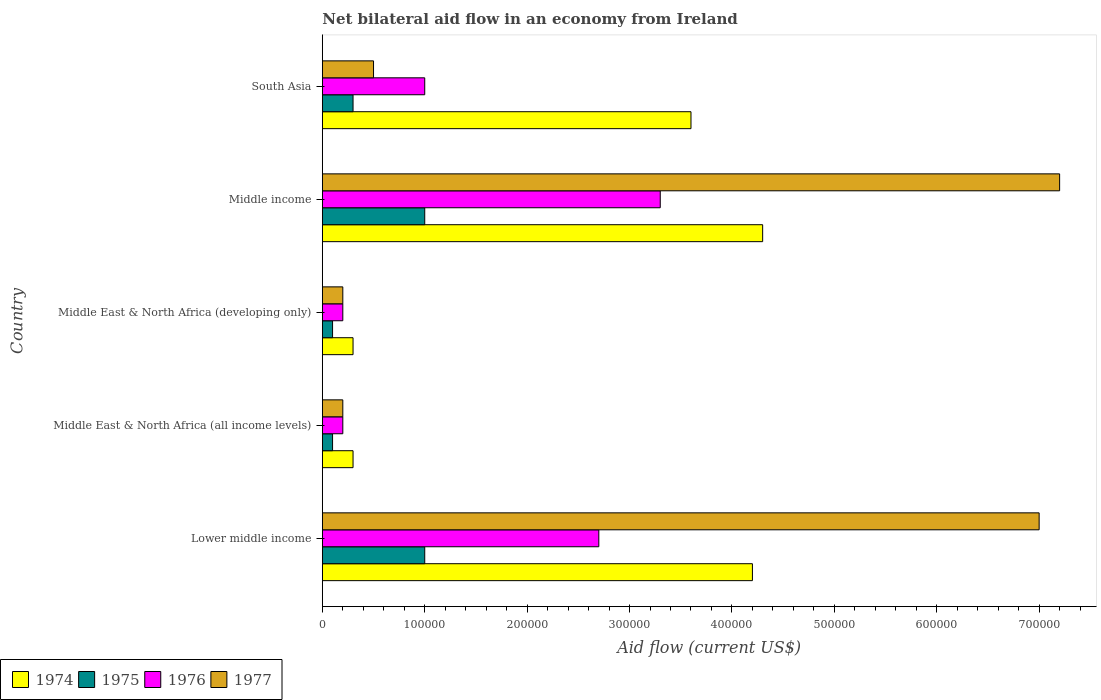How many different coloured bars are there?
Give a very brief answer. 4. How many groups of bars are there?
Your response must be concise. 5. Are the number of bars per tick equal to the number of legend labels?
Offer a very short reply. Yes. How many bars are there on the 1st tick from the top?
Ensure brevity in your answer.  4. How many bars are there on the 5th tick from the bottom?
Your answer should be compact. 4. What is the label of the 2nd group of bars from the top?
Offer a very short reply. Middle income. In how many cases, is the number of bars for a given country not equal to the number of legend labels?
Your answer should be compact. 0. What is the net bilateral aid flow in 1976 in South Asia?
Keep it short and to the point. 1.00e+05. Across all countries, what is the minimum net bilateral aid flow in 1977?
Give a very brief answer. 2.00e+04. In which country was the net bilateral aid flow in 1975 maximum?
Your response must be concise. Lower middle income. In which country was the net bilateral aid flow in 1977 minimum?
Your answer should be very brief. Middle East & North Africa (all income levels). What is the total net bilateral aid flow in 1977 in the graph?
Your answer should be compact. 1.51e+06. What is the difference between the net bilateral aid flow in 1974 in Middle income and that in South Asia?
Ensure brevity in your answer.  7.00e+04. What is the difference between the net bilateral aid flow in 1975 in Lower middle income and the net bilateral aid flow in 1976 in Middle income?
Ensure brevity in your answer.  -2.30e+05. What is the average net bilateral aid flow in 1977 per country?
Make the answer very short. 3.02e+05. What is the difference between the net bilateral aid flow in 1977 and net bilateral aid flow in 1974 in Middle East & North Africa (all income levels)?
Your response must be concise. -10000. What is the ratio of the net bilateral aid flow in 1976 in Middle East & North Africa (all income levels) to that in Middle income?
Ensure brevity in your answer.  0.06. Is the net bilateral aid flow in 1976 in Middle income less than that in South Asia?
Offer a terse response. No. What is the difference between the highest and the second highest net bilateral aid flow in 1975?
Provide a short and direct response. 0. What is the difference between the highest and the lowest net bilateral aid flow in 1976?
Your response must be concise. 3.10e+05. Is it the case that in every country, the sum of the net bilateral aid flow in 1974 and net bilateral aid flow in 1975 is greater than the sum of net bilateral aid flow in 1977 and net bilateral aid flow in 1976?
Provide a succinct answer. No. What does the 1st bar from the top in Lower middle income represents?
Provide a succinct answer. 1977. What does the 1st bar from the bottom in Middle East & North Africa (all income levels) represents?
Ensure brevity in your answer.  1974. Is it the case that in every country, the sum of the net bilateral aid flow in 1975 and net bilateral aid flow in 1974 is greater than the net bilateral aid flow in 1977?
Make the answer very short. No. Are all the bars in the graph horizontal?
Provide a short and direct response. Yes. What is the difference between two consecutive major ticks on the X-axis?
Your answer should be compact. 1.00e+05. Does the graph contain any zero values?
Your answer should be compact. No. Where does the legend appear in the graph?
Your answer should be very brief. Bottom left. How many legend labels are there?
Ensure brevity in your answer.  4. What is the title of the graph?
Offer a terse response. Net bilateral aid flow in an economy from Ireland. Does "1995" appear as one of the legend labels in the graph?
Provide a short and direct response. No. What is the Aid flow (current US$) of 1974 in Lower middle income?
Keep it short and to the point. 4.20e+05. What is the Aid flow (current US$) of 1975 in Lower middle income?
Keep it short and to the point. 1.00e+05. What is the Aid flow (current US$) in 1974 in Middle East & North Africa (all income levels)?
Offer a terse response. 3.00e+04. What is the Aid flow (current US$) in 1975 in Middle East & North Africa (all income levels)?
Your answer should be compact. 10000. What is the Aid flow (current US$) of 1976 in Middle East & North Africa (all income levels)?
Your response must be concise. 2.00e+04. What is the Aid flow (current US$) in 1976 in Middle East & North Africa (developing only)?
Keep it short and to the point. 2.00e+04. What is the Aid flow (current US$) in 1977 in Middle East & North Africa (developing only)?
Make the answer very short. 2.00e+04. What is the Aid flow (current US$) of 1975 in Middle income?
Your response must be concise. 1.00e+05. What is the Aid flow (current US$) of 1976 in Middle income?
Keep it short and to the point. 3.30e+05. What is the Aid flow (current US$) in 1977 in Middle income?
Your answer should be compact. 7.20e+05. What is the Aid flow (current US$) in 1975 in South Asia?
Your answer should be very brief. 3.00e+04. What is the Aid flow (current US$) of 1977 in South Asia?
Your answer should be compact. 5.00e+04. Across all countries, what is the maximum Aid flow (current US$) in 1976?
Provide a succinct answer. 3.30e+05. Across all countries, what is the maximum Aid flow (current US$) in 1977?
Keep it short and to the point. 7.20e+05. Across all countries, what is the minimum Aid flow (current US$) of 1975?
Give a very brief answer. 10000. Across all countries, what is the minimum Aid flow (current US$) of 1976?
Offer a very short reply. 2.00e+04. Across all countries, what is the minimum Aid flow (current US$) of 1977?
Give a very brief answer. 2.00e+04. What is the total Aid flow (current US$) in 1974 in the graph?
Offer a terse response. 1.27e+06. What is the total Aid flow (current US$) in 1976 in the graph?
Offer a very short reply. 7.40e+05. What is the total Aid flow (current US$) in 1977 in the graph?
Your answer should be very brief. 1.51e+06. What is the difference between the Aid flow (current US$) of 1977 in Lower middle income and that in Middle East & North Africa (all income levels)?
Make the answer very short. 6.80e+05. What is the difference between the Aid flow (current US$) in 1974 in Lower middle income and that in Middle East & North Africa (developing only)?
Make the answer very short. 3.90e+05. What is the difference between the Aid flow (current US$) of 1976 in Lower middle income and that in Middle East & North Africa (developing only)?
Offer a very short reply. 2.50e+05. What is the difference between the Aid flow (current US$) of 1977 in Lower middle income and that in Middle East & North Africa (developing only)?
Your response must be concise. 6.80e+05. What is the difference between the Aid flow (current US$) in 1975 in Lower middle income and that in Middle income?
Your answer should be compact. 0. What is the difference between the Aid flow (current US$) of 1974 in Lower middle income and that in South Asia?
Make the answer very short. 6.00e+04. What is the difference between the Aid flow (current US$) in 1977 in Lower middle income and that in South Asia?
Provide a short and direct response. 6.50e+05. What is the difference between the Aid flow (current US$) of 1974 in Middle East & North Africa (all income levels) and that in Middle East & North Africa (developing only)?
Provide a succinct answer. 0. What is the difference between the Aid flow (current US$) in 1975 in Middle East & North Africa (all income levels) and that in Middle East & North Africa (developing only)?
Provide a short and direct response. 0. What is the difference between the Aid flow (current US$) of 1974 in Middle East & North Africa (all income levels) and that in Middle income?
Your response must be concise. -4.00e+05. What is the difference between the Aid flow (current US$) of 1975 in Middle East & North Africa (all income levels) and that in Middle income?
Keep it short and to the point. -9.00e+04. What is the difference between the Aid flow (current US$) in 1976 in Middle East & North Africa (all income levels) and that in Middle income?
Give a very brief answer. -3.10e+05. What is the difference between the Aid flow (current US$) in 1977 in Middle East & North Africa (all income levels) and that in Middle income?
Offer a very short reply. -7.00e+05. What is the difference between the Aid flow (current US$) of 1974 in Middle East & North Africa (all income levels) and that in South Asia?
Make the answer very short. -3.30e+05. What is the difference between the Aid flow (current US$) of 1974 in Middle East & North Africa (developing only) and that in Middle income?
Ensure brevity in your answer.  -4.00e+05. What is the difference between the Aid flow (current US$) in 1976 in Middle East & North Africa (developing only) and that in Middle income?
Provide a short and direct response. -3.10e+05. What is the difference between the Aid flow (current US$) of 1977 in Middle East & North Africa (developing only) and that in Middle income?
Provide a succinct answer. -7.00e+05. What is the difference between the Aid flow (current US$) of 1974 in Middle East & North Africa (developing only) and that in South Asia?
Your answer should be compact. -3.30e+05. What is the difference between the Aid flow (current US$) of 1974 in Middle income and that in South Asia?
Provide a short and direct response. 7.00e+04. What is the difference between the Aid flow (current US$) of 1977 in Middle income and that in South Asia?
Provide a short and direct response. 6.70e+05. What is the difference between the Aid flow (current US$) of 1974 in Lower middle income and the Aid flow (current US$) of 1975 in Middle East & North Africa (all income levels)?
Give a very brief answer. 4.10e+05. What is the difference between the Aid flow (current US$) of 1974 in Lower middle income and the Aid flow (current US$) of 1977 in Middle East & North Africa (all income levels)?
Give a very brief answer. 4.00e+05. What is the difference between the Aid flow (current US$) in 1976 in Lower middle income and the Aid flow (current US$) in 1977 in Middle East & North Africa (all income levels)?
Provide a succinct answer. 2.50e+05. What is the difference between the Aid flow (current US$) in 1974 in Lower middle income and the Aid flow (current US$) in 1976 in Middle East & North Africa (developing only)?
Your answer should be compact. 4.00e+05. What is the difference between the Aid flow (current US$) in 1974 in Lower middle income and the Aid flow (current US$) in 1977 in Middle East & North Africa (developing only)?
Make the answer very short. 4.00e+05. What is the difference between the Aid flow (current US$) in 1974 in Lower middle income and the Aid flow (current US$) in 1977 in Middle income?
Provide a short and direct response. -3.00e+05. What is the difference between the Aid flow (current US$) in 1975 in Lower middle income and the Aid flow (current US$) in 1976 in Middle income?
Provide a short and direct response. -2.30e+05. What is the difference between the Aid flow (current US$) of 1975 in Lower middle income and the Aid flow (current US$) of 1977 in Middle income?
Offer a terse response. -6.20e+05. What is the difference between the Aid flow (current US$) of 1976 in Lower middle income and the Aid flow (current US$) of 1977 in Middle income?
Ensure brevity in your answer.  -4.50e+05. What is the difference between the Aid flow (current US$) of 1974 in Lower middle income and the Aid flow (current US$) of 1975 in South Asia?
Provide a succinct answer. 3.90e+05. What is the difference between the Aid flow (current US$) of 1974 in Lower middle income and the Aid flow (current US$) of 1976 in South Asia?
Offer a terse response. 3.20e+05. What is the difference between the Aid flow (current US$) of 1974 in Middle East & North Africa (all income levels) and the Aid flow (current US$) of 1977 in Middle income?
Make the answer very short. -6.90e+05. What is the difference between the Aid flow (current US$) of 1975 in Middle East & North Africa (all income levels) and the Aid flow (current US$) of 1976 in Middle income?
Ensure brevity in your answer.  -3.20e+05. What is the difference between the Aid flow (current US$) in 1975 in Middle East & North Africa (all income levels) and the Aid flow (current US$) in 1977 in Middle income?
Provide a succinct answer. -7.10e+05. What is the difference between the Aid flow (current US$) of 1976 in Middle East & North Africa (all income levels) and the Aid flow (current US$) of 1977 in Middle income?
Your answer should be compact. -7.00e+05. What is the difference between the Aid flow (current US$) in 1974 in Middle East & North Africa (all income levels) and the Aid flow (current US$) in 1975 in South Asia?
Make the answer very short. 0. What is the difference between the Aid flow (current US$) in 1974 in Middle East & North Africa (all income levels) and the Aid flow (current US$) in 1977 in South Asia?
Offer a terse response. -2.00e+04. What is the difference between the Aid flow (current US$) in 1975 in Middle East & North Africa (all income levels) and the Aid flow (current US$) in 1976 in South Asia?
Your answer should be very brief. -9.00e+04. What is the difference between the Aid flow (current US$) of 1976 in Middle East & North Africa (all income levels) and the Aid flow (current US$) of 1977 in South Asia?
Give a very brief answer. -3.00e+04. What is the difference between the Aid flow (current US$) in 1974 in Middle East & North Africa (developing only) and the Aid flow (current US$) in 1976 in Middle income?
Provide a short and direct response. -3.00e+05. What is the difference between the Aid flow (current US$) in 1974 in Middle East & North Africa (developing only) and the Aid flow (current US$) in 1977 in Middle income?
Offer a terse response. -6.90e+05. What is the difference between the Aid flow (current US$) in 1975 in Middle East & North Africa (developing only) and the Aid flow (current US$) in 1976 in Middle income?
Your response must be concise. -3.20e+05. What is the difference between the Aid flow (current US$) of 1975 in Middle East & North Africa (developing only) and the Aid flow (current US$) of 1977 in Middle income?
Offer a very short reply. -7.10e+05. What is the difference between the Aid flow (current US$) in 1976 in Middle East & North Africa (developing only) and the Aid flow (current US$) in 1977 in Middle income?
Provide a short and direct response. -7.00e+05. What is the difference between the Aid flow (current US$) in 1975 in Middle East & North Africa (developing only) and the Aid flow (current US$) in 1976 in South Asia?
Ensure brevity in your answer.  -9.00e+04. What is the difference between the Aid flow (current US$) of 1975 in Middle income and the Aid flow (current US$) of 1977 in South Asia?
Give a very brief answer. 5.00e+04. What is the average Aid flow (current US$) in 1974 per country?
Ensure brevity in your answer.  2.54e+05. What is the average Aid flow (current US$) of 1975 per country?
Your response must be concise. 5.00e+04. What is the average Aid flow (current US$) of 1976 per country?
Offer a terse response. 1.48e+05. What is the average Aid flow (current US$) of 1977 per country?
Provide a short and direct response. 3.02e+05. What is the difference between the Aid flow (current US$) in 1974 and Aid flow (current US$) in 1975 in Lower middle income?
Give a very brief answer. 3.20e+05. What is the difference between the Aid flow (current US$) of 1974 and Aid flow (current US$) of 1976 in Lower middle income?
Your answer should be compact. 1.50e+05. What is the difference between the Aid flow (current US$) of 1974 and Aid flow (current US$) of 1977 in Lower middle income?
Make the answer very short. -2.80e+05. What is the difference between the Aid flow (current US$) in 1975 and Aid flow (current US$) in 1977 in Lower middle income?
Your answer should be very brief. -6.00e+05. What is the difference between the Aid flow (current US$) of 1976 and Aid flow (current US$) of 1977 in Lower middle income?
Keep it short and to the point. -4.30e+05. What is the difference between the Aid flow (current US$) of 1974 and Aid flow (current US$) of 1977 in Middle East & North Africa (all income levels)?
Provide a short and direct response. 10000. What is the difference between the Aid flow (current US$) in 1975 and Aid flow (current US$) in 1977 in Middle East & North Africa (all income levels)?
Your response must be concise. -10000. What is the difference between the Aid flow (current US$) of 1976 and Aid flow (current US$) of 1977 in Middle East & North Africa (all income levels)?
Your answer should be compact. 0. What is the difference between the Aid flow (current US$) in 1974 and Aid flow (current US$) in 1975 in Middle East & North Africa (developing only)?
Offer a terse response. 2.00e+04. What is the difference between the Aid flow (current US$) in 1974 and Aid flow (current US$) in 1977 in Middle East & North Africa (developing only)?
Your answer should be very brief. 10000. What is the difference between the Aid flow (current US$) in 1975 and Aid flow (current US$) in 1976 in Middle East & North Africa (developing only)?
Offer a terse response. -10000. What is the difference between the Aid flow (current US$) of 1976 and Aid flow (current US$) of 1977 in Middle East & North Africa (developing only)?
Your response must be concise. 0. What is the difference between the Aid flow (current US$) in 1975 and Aid flow (current US$) in 1977 in Middle income?
Give a very brief answer. -6.20e+05. What is the difference between the Aid flow (current US$) in 1976 and Aid flow (current US$) in 1977 in Middle income?
Ensure brevity in your answer.  -3.90e+05. What is the difference between the Aid flow (current US$) in 1974 and Aid flow (current US$) in 1976 in South Asia?
Offer a terse response. 2.60e+05. What is the difference between the Aid flow (current US$) in 1974 and Aid flow (current US$) in 1977 in South Asia?
Make the answer very short. 3.10e+05. What is the difference between the Aid flow (current US$) of 1975 and Aid flow (current US$) of 1976 in South Asia?
Your response must be concise. -7.00e+04. What is the difference between the Aid flow (current US$) in 1976 and Aid flow (current US$) in 1977 in South Asia?
Your response must be concise. 5.00e+04. What is the ratio of the Aid flow (current US$) of 1974 in Lower middle income to that in Middle East & North Africa (all income levels)?
Your answer should be very brief. 14. What is the ratio of the Aid flow (current US$) of 1975 in Lower middle income to that in Middle East & North Africa (all income levels)?
Provide a succinct answer. 10. What is the ratio of the Aid flow (current US$) in 1974 in Lower middle income to that in Middle East & North Africa (developing only)?
Your answer should be very brief. 14. What is the ratio of the Aid flow (current US$) in 1976 in Lower middle income to that in Middle East & North Africa (developing only)?
Offer a terse response. 13.5. What is the ratio of the Aid flow (current US$) in 1974 in Lower middle income to that in Middle income?
Your answer should be very brief. 0.98. What is the ratio of the Aid flow (current US$) of 1975 in Lower middle income to that in Middle income?
Your answer should be compact. 1. What is the ratio of the Aid flow (current US$) in 1976 in Lower middle income to that in Middle income?
Ensure brevity in your answer.  0.82. What is the ratio of the Aid flow (current US$) in 1977 in Lower middle income to that in Middle income?
Give a very brief answer. 0.97. What is the ratio of the Aid flow (current US$) of 1974 in Lower middle income to that in South Asia?
Provide a succinct answer. 1.17. What is the ratio of the Aid flow (current US$) in 1975 in Lower middle income to that in South Asia?
Make the answer very short. 3.33. What is the ratio of the Aid flow (current US$) of 1977 in Lower middle income to that in South Asia?
Your answer should be very brief. 14. What is the ratio of the Aid flow (current US$) in 1976 in Middle East & North Africa (all income levels) to that in Middle East & North Africa (developing only)?
Make the answer very short. 1. What is the ratio of the Aid flow (current US$) of 1974 in Middle East & North Africa (all income levels) to that in Middle income?
Offer a terse response. 0.07. What is the ratio of the Aid flow (current US$) of 1975 in Middle East & North Africa (all income levels) to that in Middle income?
Your response must be concise. 0.1. What is the ratio of the Aid flow (current US$) in 1976 in Middle East & North Africa (all income levels) to that in Middle income?
Your answer should be compact. 0.06. What is the ratio of the Aid flow (current US$) in 1977 in Middle East & North Africa (all income levels) to that in Middle income?
Offer a terse response. 0.03. What is the ratio of the Aid flow (current US$) in 1974 in Middle East & North Africa (all income levels) to that in South Asia?
Offer a terse response. 0.08. What is the ratio of the Aid flow (current US$) of 1976 in Middle East & North Africa (all income levels) to that in South Asia?
Provide a short and direct response. 0.2. What is the ratio of the Aid flow (current US$) of 1977 in Middle East & North Africa (all income levels) to that in South Asia?
Keep it short and to the point. 0.4. What is the ratio of the Aid flow (current US$) in 1974 in Middle East & North Africa (developing only) to that in Middle income?
Offer a very short reply. 0.07. What is the ratio of the Aid flow (current US$) of 1976 in Middle East & North Africa (developing only) to that in Middle income?
Offer a terse response. 0.06. What is the ratio of the Aid flow (current US$) in 1977 in Middle East & North Africa (developing only) to that in Middle income?
Offer a very short reply. 0.03. What is the ratio of the Aid flow (current US$) of 1974 in Middle East & North Africa (developing only) to that in South Asia?
Your answer should be compact. 0.08. What is the ratio of the Aid flow (current US$) in 1975 in Middle East & North Africa (developing only) to that in South Asia?
Provide a short and direct response. 0.33. What is the ratio of the Aid flow (current US$) of 1974 in Middle income to that in South Asia?
Ensure brevity in your answer.  1.19. What is the difference between the highest and the second highest Aid flow (current US$) in 1977?
Make the answer very short. 2.00e+04. What is the difference between the highest and the lowest Aid flow (current US$) in 1974?
Provide a short and direct response. 4.00e+05. What is the difference between the highest and the lowest Aid flow (current US$) of 1977?
Offer a very short reply. 7.00e+05. 